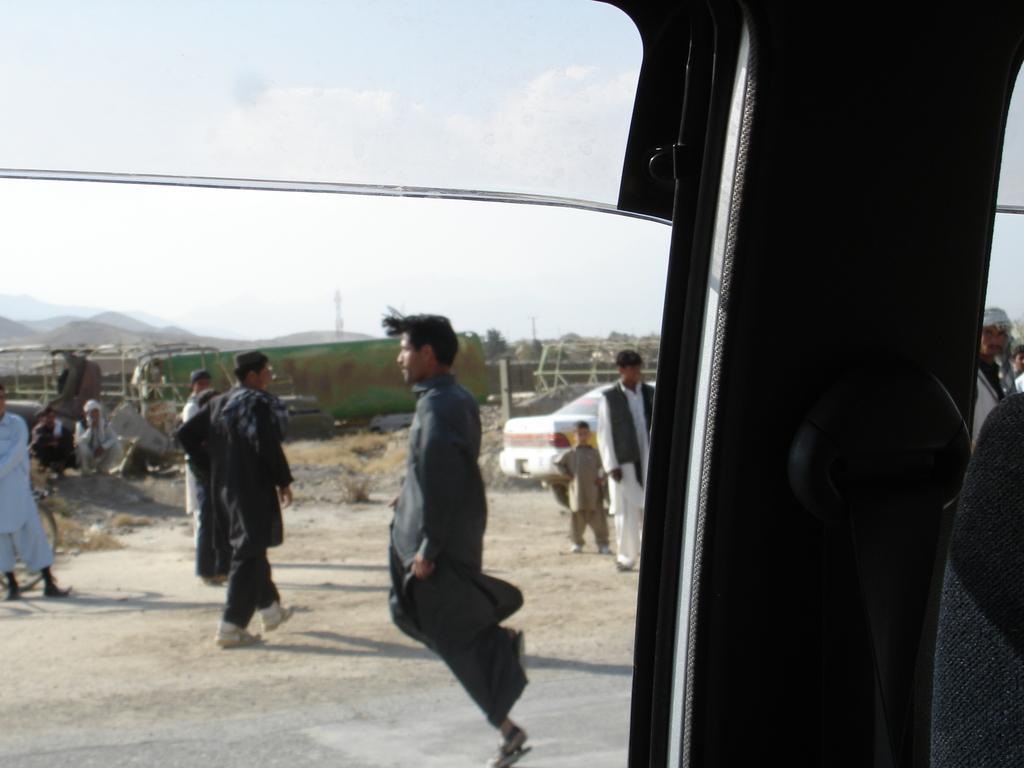Please provide a concise description of this image. In this image I can see a picture through the glass window of the vehicle. I can see few persons standing on the ground, a white colored car, few trees, few mountains and the sky. 